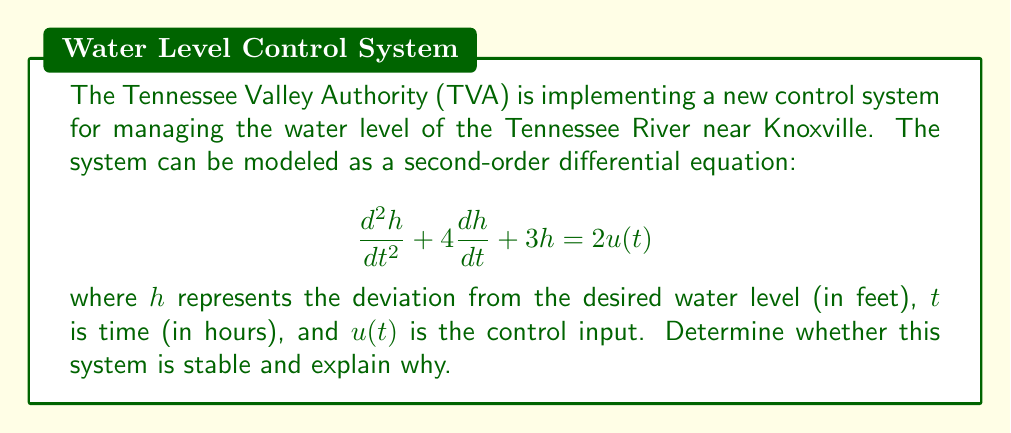Solve this math problem. To analyze the stability of this system, we need to examine the characteristic equation of the homogeneous part of the differential equation.

1. The homogeneous equation is:
   $$\frac{d^2h}{dt^2} + 4\frac{dh}{dt} + 3h = 0$$

2. The characteristic equation is obtained by substituting $h = e^{\lambda t}$:
   $$\lambda^2 + 4\lambda + 3 = 0$$

3. This is a quadratic equation in the form $a\lambda^2 + b\lambda + c = 0$, where $a=1$, $b=4$, and $c=3$.

4. We can solve this using the quadratic formula: $\lambda = \frac{-b \pm \sqrt{b^2 - 4ac}}{2a}$

5. Substituting the values:
   $$\lambda = \frac{-4 \pm \sqrt{4^2 - 4(1)(3)}}{2(1)} = \frac{-4 \pm \sqrt{16 - 12}}{2} = \frac{-4 \pm \sqrt{4}}{2} = \frac{-4 \pm 2}{2}$$

6. This gives us two roots:
   $$\lambda_1 = \frac{-4 + 2}{2} = -1$$
   $$\lambda_2 = \frac{-4 - 2}{2} = -3$$

7. For a second-order system to be stable, both roots of the characteristic equation must have negative real parts.

8. In this case, both $\lambda_1$ and $\lambda_2$ are real and negative.

Therefore, the system is stable. This means that any disturbances in the water level will naturally decay over time, returning the system to its equilibrium state without oscillations.
Answer: The system is stable because both roots of the characteristic equation ($\lambda_1 = -1$ and $\lambda_2 = -3$) are real and negative. 